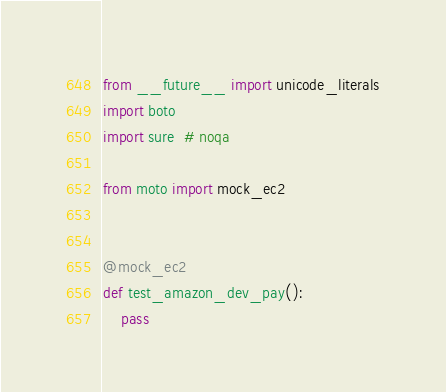Convert code to text. <code><loc_0><loc_0><loc_500><loc_500><_Python_>from __future__ import unicode_literals
import boto
import sure  # noqa

from moto import mock_ec2


@mock_ec2
def test_amazon_dev_pay():
    pass
</code> 